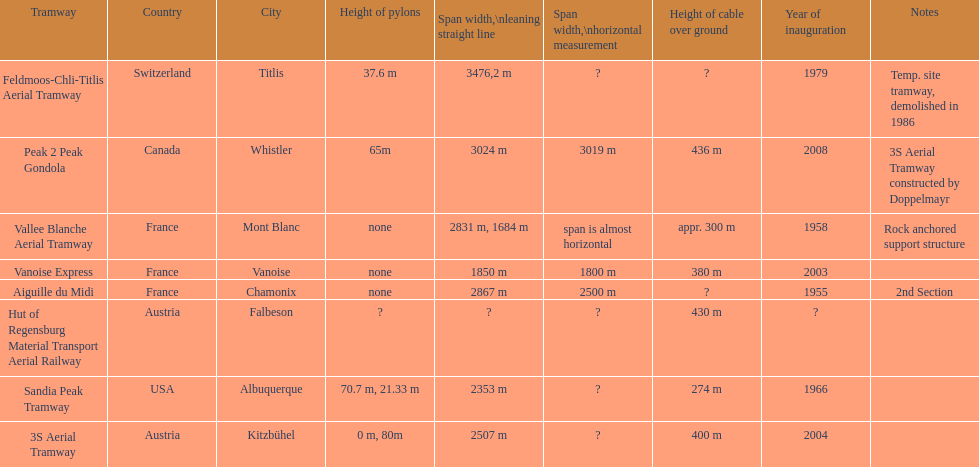Which tramway was inaugurated first, the 3s aerial tramway or the aiguille du midi? Aiguille du Midi. 